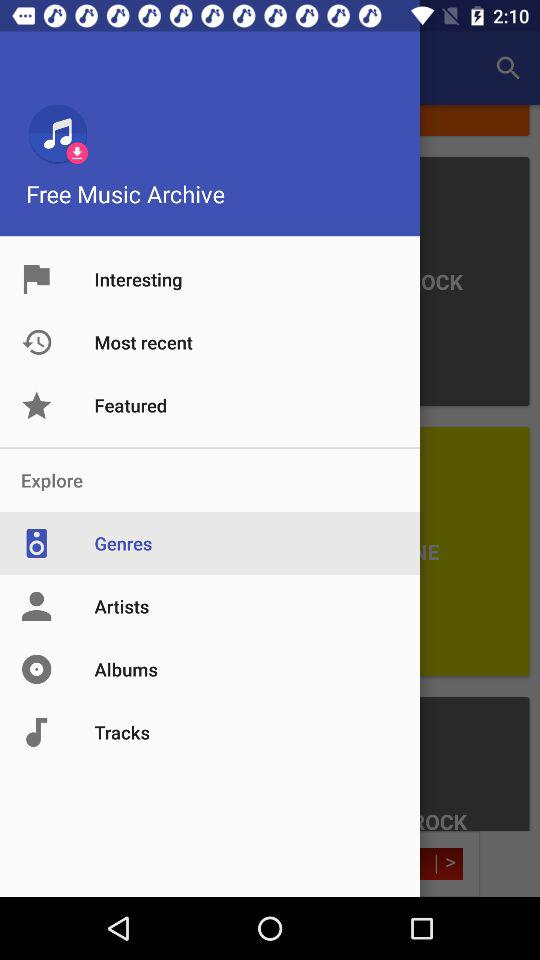What is the application name? The application name is "Free Music Archive". 